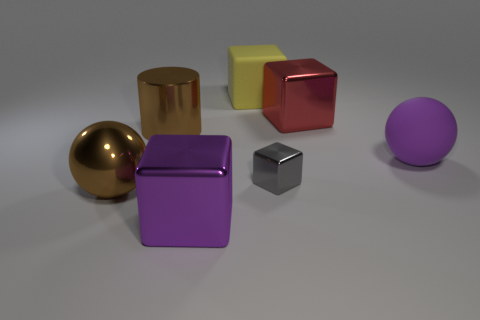Are there any other things that are the same size as the gray block?
Your answer should be compact. No. What number of shiny objects have the same shape as the big purple matte object?
Your response must be concise. 1. Is the color of the ball behind the tiny metal block the same as the large shiny cube that is in front of the gray thing?
Provide a succinct answer. Yes. What number of things are either big purple matte cubes or red metal things?
Your answer should be very brief. 1. How many large purple things are the same material as the large yellow cube?
Ensure brevity in your answer.  1. Are there fewer gray things than gray rubber things?
Provide a succinct answer. No. Are the block behind the big red metal thing and the brown ball made of the same material?
Your answer should be compact. No. What number of cylinders are either large rubber objects or big purple things?
Your answer should be compact. 0. There is a object that is both behind the brown cylinder and to the left of the big red metal cube; what shape is it?
Your answer should be compact. Cube. There is a cube in front of the tiny gray object that is on the left side of the block right of the tiny gray thing; what color is it?
Ensure brevity in your answer.  Purple. 